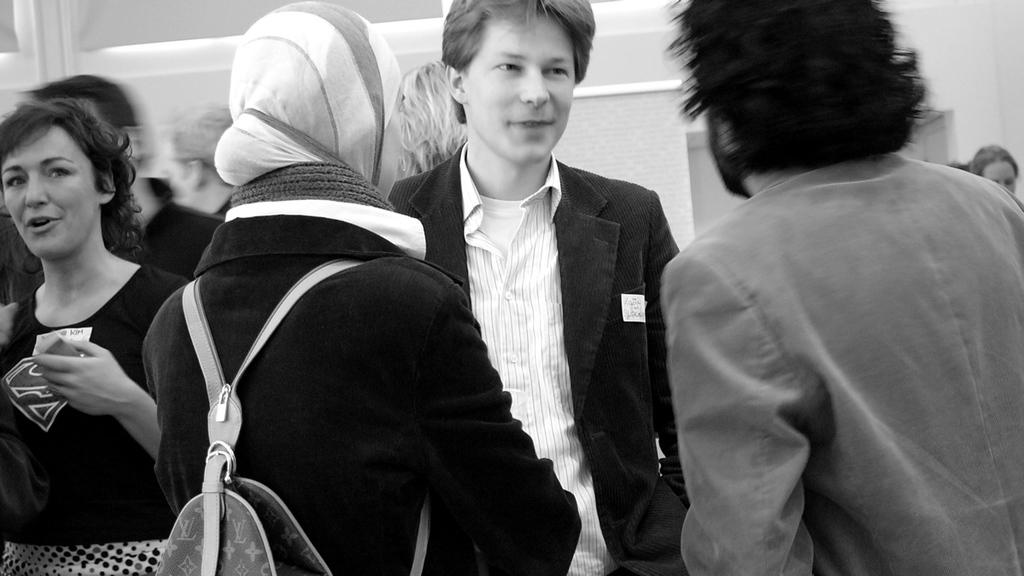What is the main subject of the image? The main subject of the image is a group of people. What are the people in the image doing? The people are standing. Can you describe the appearance of one person in the group? One person in front is wearing a bag. What is the color scheme of the image? The image is in black and white. What type of boats can be seen in the image? There are no boats present in the image. How does the process of digestion appear in the image? The process of digestion is not depicted in the image. 